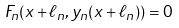<formula> <loc_0><loc_0><loc_500><loc_500>F _ { n } ( x + \ell _ { n } , y _ { n } ( x + \ell _ { n } ) ) = 0</formula> 